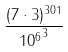Convert formula to latex. <formula><loc_0><loc_0><loc_500><loc_500>\frac { ( 7 \cdot 3 ) ^ { 3 0 1 } } { { 1 0 ^ { 6 } } ^ { 3 } }</formula> 